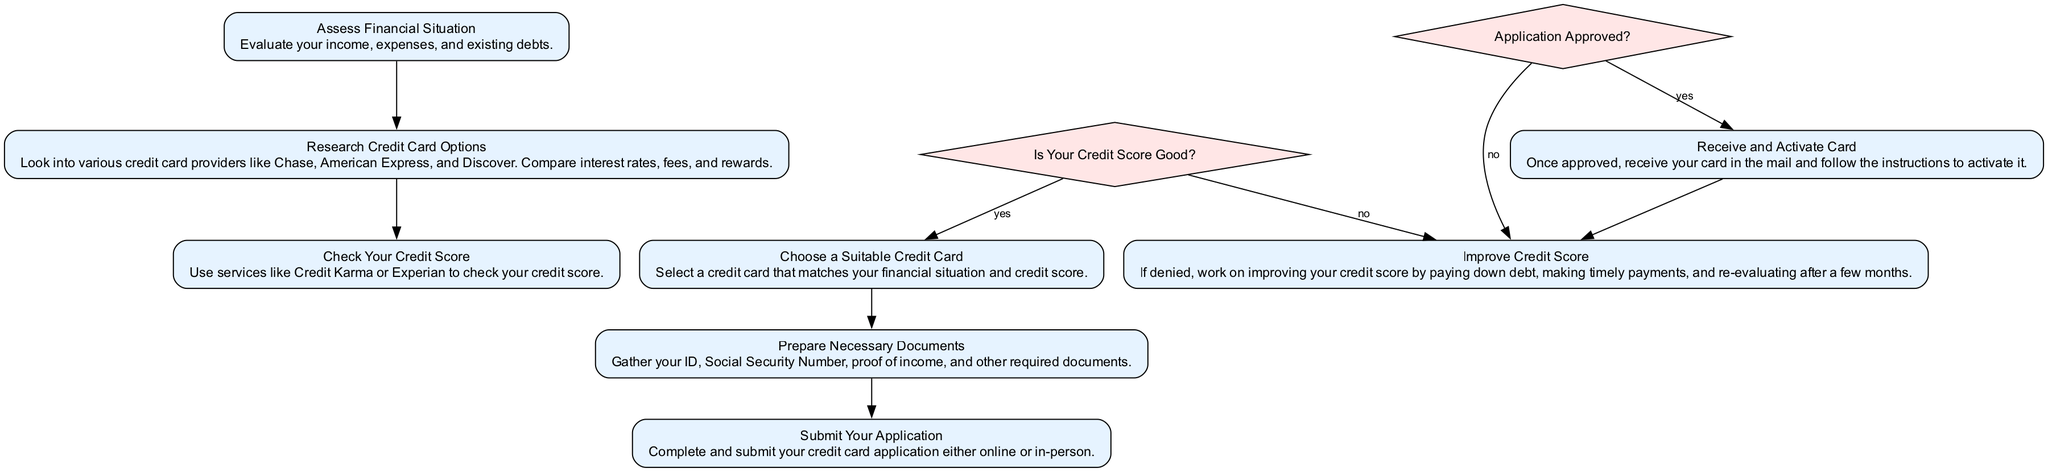What is the first step in the credit card application process? The first step listed in the diagram is "Assess Financial Situation." This is indicated at the top of the flow chart and begins the sequence of steps.
Answer: Assess Financial Situation How many decision points are in this diagram? There are two decision points in the flow chart, identified as "Is Your Credit Score Good?" and "Application Approved?". They are shown as diamond-shaped nodes.
Answer: 2 What happens if your credit score is not good? If the credit score is not good, according to the decision point "Is Your Credit Score Good?", the next step is "Improve Credit Score." This connects directly from the decision indicating a negative result.
Answer: Improve Credit Score What document do you need to prepare before submitting your application? You need to prepare "ID, Social Security Number, proof of income, and other required documents." This is outlined in the step identifying document preparation.
Answer: ID, Social Security Number, proof of income, and other required documents What is the final step if your application is approved? If the application is approved, the final step indicated is "Receive and Activate Card." This describes what to expect once approval is granted.
Answer: Receive and Activate Card What is the relationship between "Check Your Credit Score" and "Choose a Suitable Credit Card"? "Check Your Credit Score" is a prerequisite to "Choose a Suitable Credit Card." After checking the credit score, the next logical step, if the score is good, is to choose the card. This shows a sequential flow from one step to another.
Answer: Prerequisite What documents are necessary at step 5? Step 5 mentions "ID, Social Security Number, proof of income, and other required documents" as necessary documents to prepare. This is a direct reference from that specific step in the flow chart.
Answer: ID, Social Security Number, proof of income, and other required documents What does the decision "Application Approved?" lead to if the answer is yes? If the application is approved, the flow leads to the next step, which is "Receive and Activate Card." This outcome shows the sequence of steps based on the approval decision.
Answer: Receive and Activate Card What is the aim of the step "Improve Credit Score"? The aim of the step "Improve Credit Score" is to work on enhancing one's credit score after being denied for a credit card application and re-evaluating after a few months. This step provides actionable advice for those in that situation.
Answer: Enhance credit score 